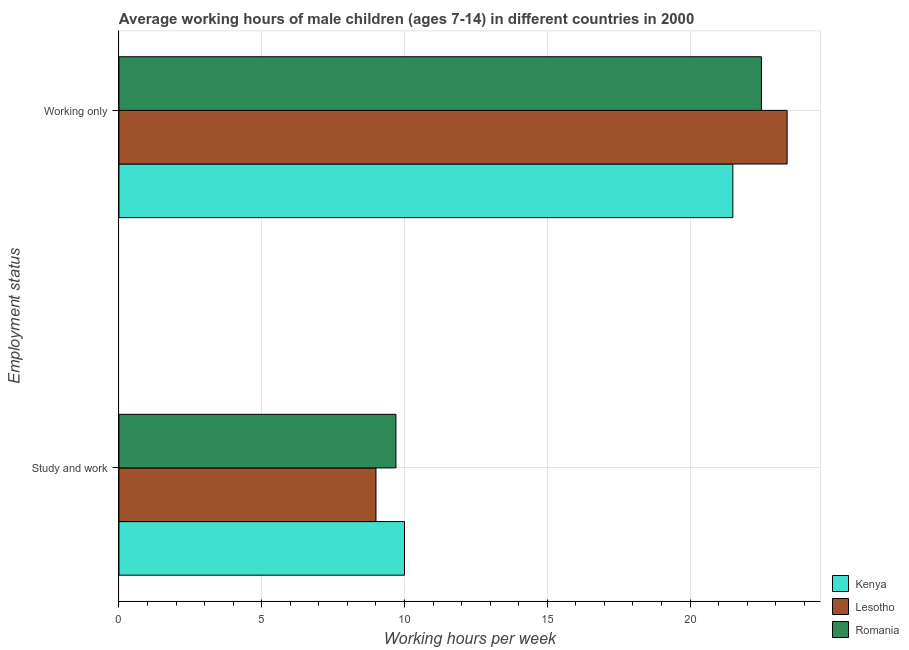How many groups of bars are there?
Keep it short and to the point. 2. How many bars are there on the 1st tick from the top?
Keep it short and to the point. 3. What is the label of the 2nd group of bars from the top?
Give a very brief answer. Study and work. What is the average working hour of children involved in study and work in Lesotho?
Provide a succinct answer. 9. In which country was the average working hour of children involved in only work maximum?
Offer a terse response. Lesotho. In which country was the average working hour of children involved in study and work minimum?
Ensure brevity in your answer.  Lesotho. What is the total average working hour of children involved in study and work in the graph?
Offer a very short reply. 28.7. What is the difference between the average working hour of children involved in only work in Lesotho and the average working hour of children involved in study and work in Kenya?
Your answer should be very brief. 13.4. What is the average average working hour of children involved in study and work per country?
Your response must be concise. 9.57. In how many countries, is the average working hour of children involved in study and work greater than 23 hours?
Offer a very short reply. 0. What does the 3rd bar from the top in Study and work represents?
Your response must be concise. Kenya. What does the 2nd bar from the bottom in Working only represents?
Give a very brief answer. Lesotho. How many bars are there?
Provide a succinct answer. 6. Are all the bars in the graph horizontal?
Your answer should be compact. Yes. How many countries are there in the graph?
Your answer should be very brief. 3. What is the difference between two consecutive major ticks on the X-axis?
Keep it short and to the point. 5. Are the values on the major ticks of X-axis written in scientific E-notation?
Your answer should be very brief. No. How many legend labels are there?
Your answer should be compact. 3. What is the title of the graph?
Offer a very short reply. Average working hours of male children (ages 7-14) in different countries in 2000. What is the label or title of the X-axis?
Provide a succinct answer. Working hours per week. What is the label or title of the Y-axis?
Give a very brief answer. Employment status. What is the Working hours per week of Lesotho in Study and work?
Offer a very short reply. 9. What is the Working hours per week in Romania in Study and work?
Your answer should be compact. 9.7. What is the Working hours per week of Lesotho in Working only?
Provide a short and direct response. 23.4. What is the Working hours per week in Romania in Working only?
Your answer should be compact. 22.5. Across all Employment status, what is the maximum Working hours per week of Kenya?
Your answer should be very brief. 21.5. Across all Employment status, what is the maximum Working hours per week of Lesotho?
Ensure brevity in your answer.  23.4. Across all Employment status, what is the maximum Working hours per week of Romania?
Offer a terse response. 22.5. Across all Employment status, what is the minimum Working hours per week of Lesotho?
Your answer should be compact. 9. Across all Employment status, what is the minimum Working hours per week in Romania?
Offer a very short reply. 9.7. What is the total Working hours per week in Kenya in the graph?
Offer a very short reply. 31.5. What is the total Working hours per week in Lesotho in the graph?
Keep it short and to the point. 32.4. What is the total Working hours per week of Romania in the graph?
Make the answer very short. 32.2. What is the difference between the Working hours per week of Kenya in Study and work and that in Working only?
Provide a short and direct response. -11.5. What is the difference between the Working hours per week of Lesotho in Study and work and that in Working only?
Your answer should be compact. -14.4. What is the difference between the Working hours per week in Romania in Study and work and that in Working only?
Keep it short and to the point. -12.8. What is the difference between the Working hours per week of Kenya in Study and work and the Working hours per week of Lesotho in Working only?
Provide a short and direct response. -13.4. What is the difference between the Working hours per week in Lesotho in Study and work and the Working hours per week in Romania in Working only?
Provide a short and direct response. -13.5. What is the average Working hours per week of Kenya per Employment status?
Keep it short and to the point. 15.75. What is the average Working hours per week of Lesotho per Employment status?
Your answer should be compact. 16.2. What is the average Working hours per week in Romania per Employment status?
Give a very brief answer. 16.1. What is the difference between the Working hours per week in Kenya and Working hours per week in Lesotho in Study and work?
Provide a succinct answer. 1. What is the difference between the Working hours per week of Lesotho and Working hours per week of Romania in Study and work?
Your response must be concise. -0.7. What is the difference between the Working hours per week of Kenya and Working hours per week of Lesotho in Working only?
Keep it short and to the point. -1.9. What is the ratio of the Working hours per week of Kenya in Study and work to that in Working only?
Make the answer very short. 0.47. What is the ratio of the Working hours per week of Lesotho in Study and work to that in Working only?
Ensure brevity in your answer.  0.38. What is the ratio of the Working hours per week of Romania in Study and work to that in Working only?
Your response must be concise. 0.43. What is the difference between the highest and the second highest Working hours per week in Kenya?
Provide a succinct answer. 11.5. What is the difference between the highest and the second highest Working hours per week in Lesotho?
Keep it short and to the point. 14.4. What is the difference between the highest and the second highest Working hours per week in Romania?
Provide a short and direct response. 12.8. What is the difference between the highest and the lowest Working hours per week of Lesotho?
Keep it short and to the point. 14.4. What is the difference between the highest and the lowest Working hours per week of Romania?
Your response must be concise. 12.8. 